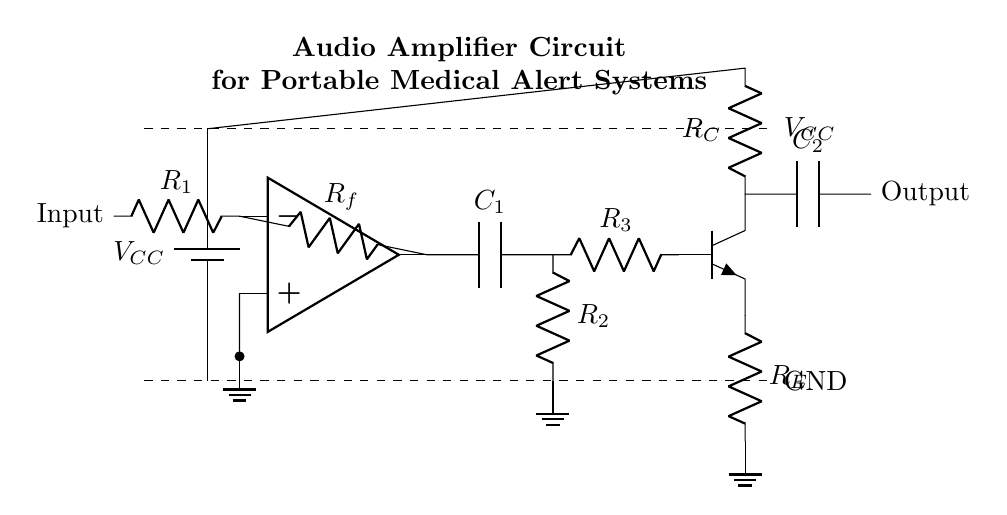What is the power supply voltage used in this circuit? The power supply voltage is denoted as V_CC in the circuit diagram, which provides the necessary potential difference for the amplifier to operate. The specific voltage value is not indicated, but it is typically 5V or similar for portable devices.
Answer: V_CC What type of amplifier is shown in this circuit? This circuit represents an operational amplifier circuit, which is designed to amplify the input audio signal significantly as required for portable medical alert systems.
Answer: Operational amplifier What components couple the input and output stages in this amplifier? The coupling capacitor, labeled C_1, connects the output of the operational amplifier to the next stage of resistors, allowing the amplified audio signal to pass while blocking any DC voltage.
Answer: C_1 How many resistors are used in the output stage? In the output stage, there are two resistors: R_E and R_C, which are used to manage the current and stabilize the transistor output of the amplifier circuit.
Answer: Two What is the purpose of capacitor C_2 in the circuit? Capacitor C_2 acts as a coupling capacitor at the output, allowing the amplified audio signal to pass to the next stage or load while preventing any DC component from reaching the output.
Answer: Coupling Is there a ground connection in this circuit? Yes, there are multiple ground connections in the circuit diagram, indicated by nodes connected to the ground symbol, ensuring a common reference point for the voltage levels in the circuit.
Answer: Yes 